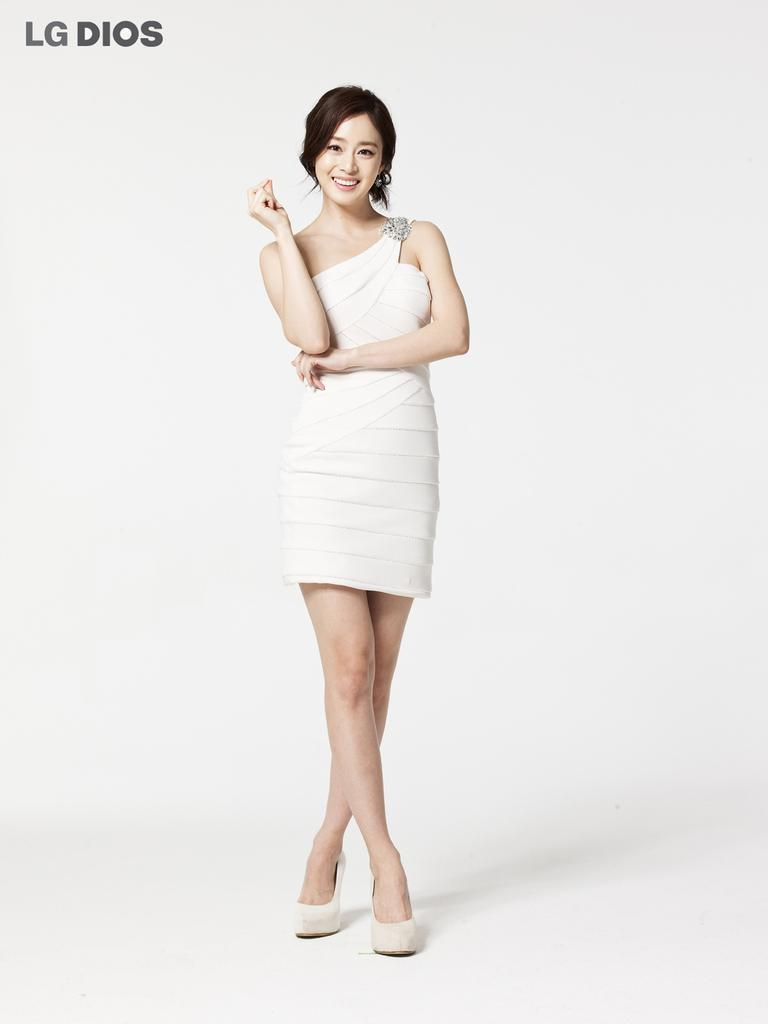Who is the main subject in the image? There is a woman in the center of the picture. What is the woman wearing? The woman is wearing a white dress. What expression does the woman have? The woman is smiling. What color is the background of the image? The background of the image is white. What can be seen at the top left of the image? There is text at the top left of the image. What type of crate is being carried by the woman in the image? There is no crate present in the image; the woman is not carrying anything. 